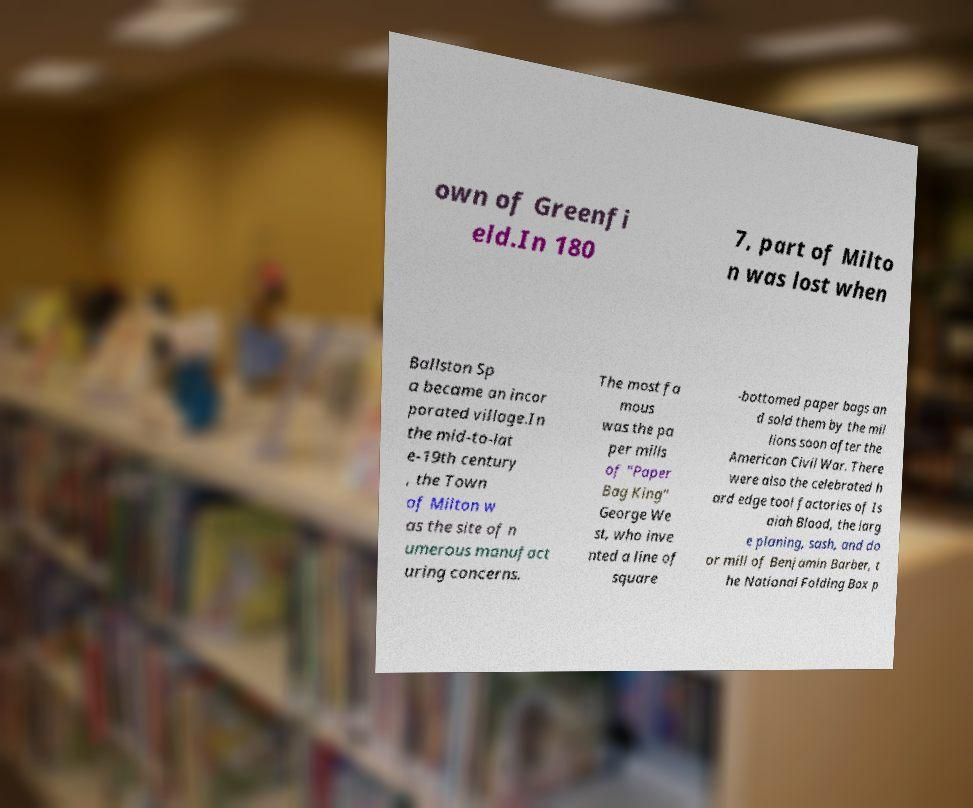For documentation purposes, I need the text within this image transcribed. Could you provide that? own of Greenfi eld.In 180 7, part of Milto n was lost when Ballston Sp a became an incor porated village.In the mid-to-lat e-19th century , the Town of Milton w as the site of n umerous manufact uring concerns. The most fa mous was the pa per mills of "Paper Bag King" George We st, who inve nted a line of square -bottomed paper bags an d sold them by the mil lions soon after the American Civil War. There were also the celebrated h ard edge tool factories of Is aiah Blood, the larg e planing, sash, and do or mill of Benjamin Barber, t he National Folding Box p 